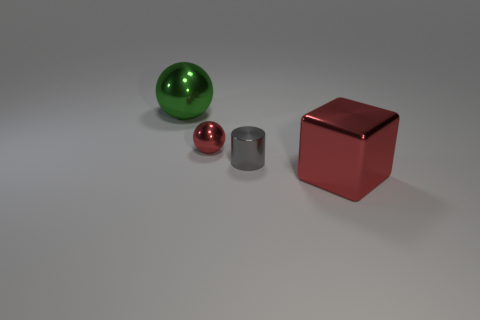What shape is the metallic thing that is the same color as the big shiny cube?
Provide a succinct answer. Sphere. Is there a red metallic sphere that is to the right of the metal ball that is in front of the large object that is on the left side of the shiny block?
Your answer should be very brief. No. There is another metallic thing that is the same size as the green metallic thing; what shape is it?
Give a very brief answer. Cube. The other small thing that is the same shape as the green thing is what color?
Ensure brevity in your answer.  Red. How many objects are tiny brown shiny spheres or balls?
Keep it short and to the point. 2. Do the red metal thing that is in front of the small ball and the large object that is to the left of the large red block have the same shape?
Your answer should be compact. No. There is a big thing that is right of the green thing; what shape is it?
Your answer should be very brief. Cube. Is the number of red balls in front of the gray metallic thing the same as the number of large green things in front of the red shiny ball?
Make the answer very short. Yes. How many objects are either large purple blocks or red things to the left of the big red cube?
Offer a very short reply. 1. The metal thing that is both behind the tiny gray cylinder and right of the green object has what shape?
Provide a succinct answer. Sphere. 